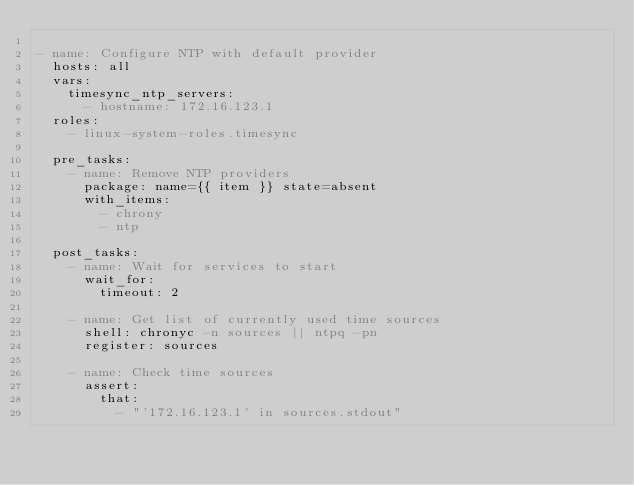<code> <loc_0><loc_0><loc_500><loc_500><_YAML_>
- name: Configure NTP with default provider
  hosts: all
  vars:
    timesync_ntp_servers:
      - hostname: 172.16.123.1
  roles:
    - linux-system-roles.timesync

  pre_tasks:
    - name: Remove NTP providers
      package: name={{ item }} state=absent
      with_items:
        - chrony
        - ntp

  post_tasks:
    - name: Wait for services to start
      wait_for:
        timeout: 2

    - name: Get list of currently used time sources
      shell: chronyc -n sources || ntpq -pn
      register: sources

    - name: Check time sources
      assert:
        that:
          - "'172.16.123.1' in sources.stdout"
</code> 